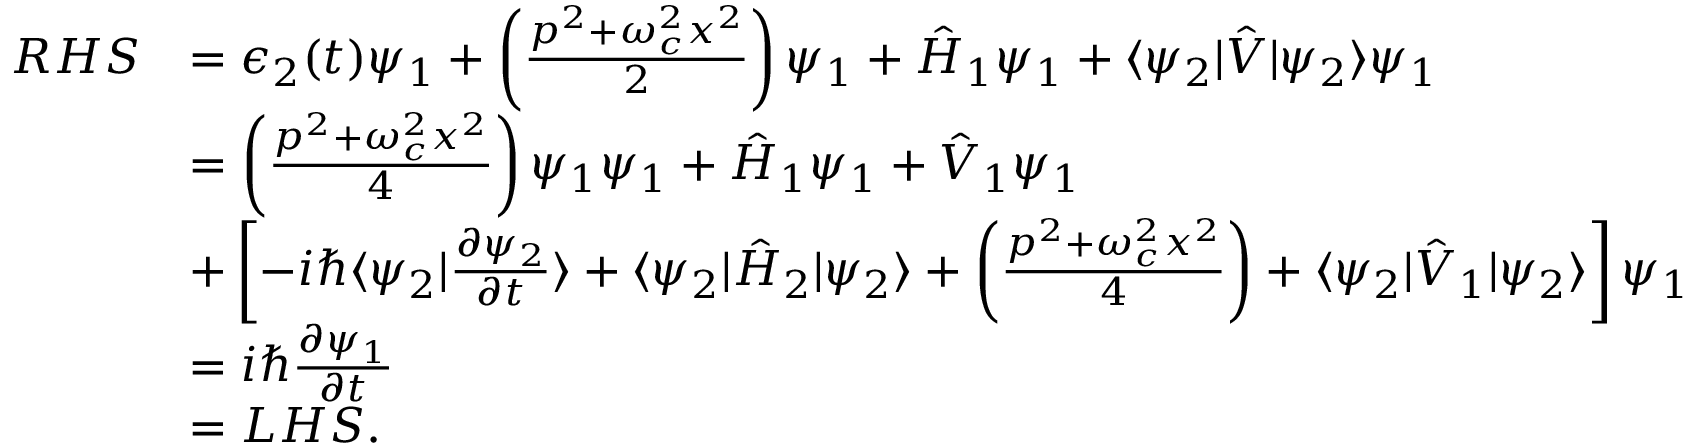<formula> <loc_0><loc_0><loc_500><loc_500>\begin{array} { r l } { R H S } & { = \epsilon _ { 2 } ( t ) \psi _ { 1 } + \left ( \frac { p ^ { 2 } + \omega _ { c } ^ { 2 } x ^ { 2 } } { 2 } \right ) \psi _ { 1 } + \hat { H } _ { 1 } \psi _ { 1 } + \langle \psi _ { 2 } | \hat { V } | \psi _ { 2 } \rangle \psi _ { 1 } } \\ & { = \left ( \frac { p ^ { 2 } + \omega _ { c } ^ { 2 } x ^ { 2 } } { 4 } \right ) \psi _ { 1 } \psi _ { 1 } + \hat { H } _ { 1 } \psi _ { 1 } + \hat { V } _ { 1 } \psi _ { 1 } } \\ & { + \left [ - i \hbar { \langle } \psi _ { 2 } | \frac { \partial \psi _ { 2 } } { \partial t } \rangle + \langle \psi _ { 2 } | \hat { H } _ { 2 } | \psi _ { 2 } \rangle + \left ( \frac { p ^ { 2 } + \omega _ { c } ^ { 2 } x ^ { 2 } } { 4 } \right ) + \langle \psi _ { 2 } | \hat { V } _ { 1 } | \psi _ { 2 } \rangle \right ] \psi _ { 1 } } \\ & { = i \hbar { } \partial \psi _ { 1 } } { \partial t } } \\ & { = L H S . } \end{array}</formula> 